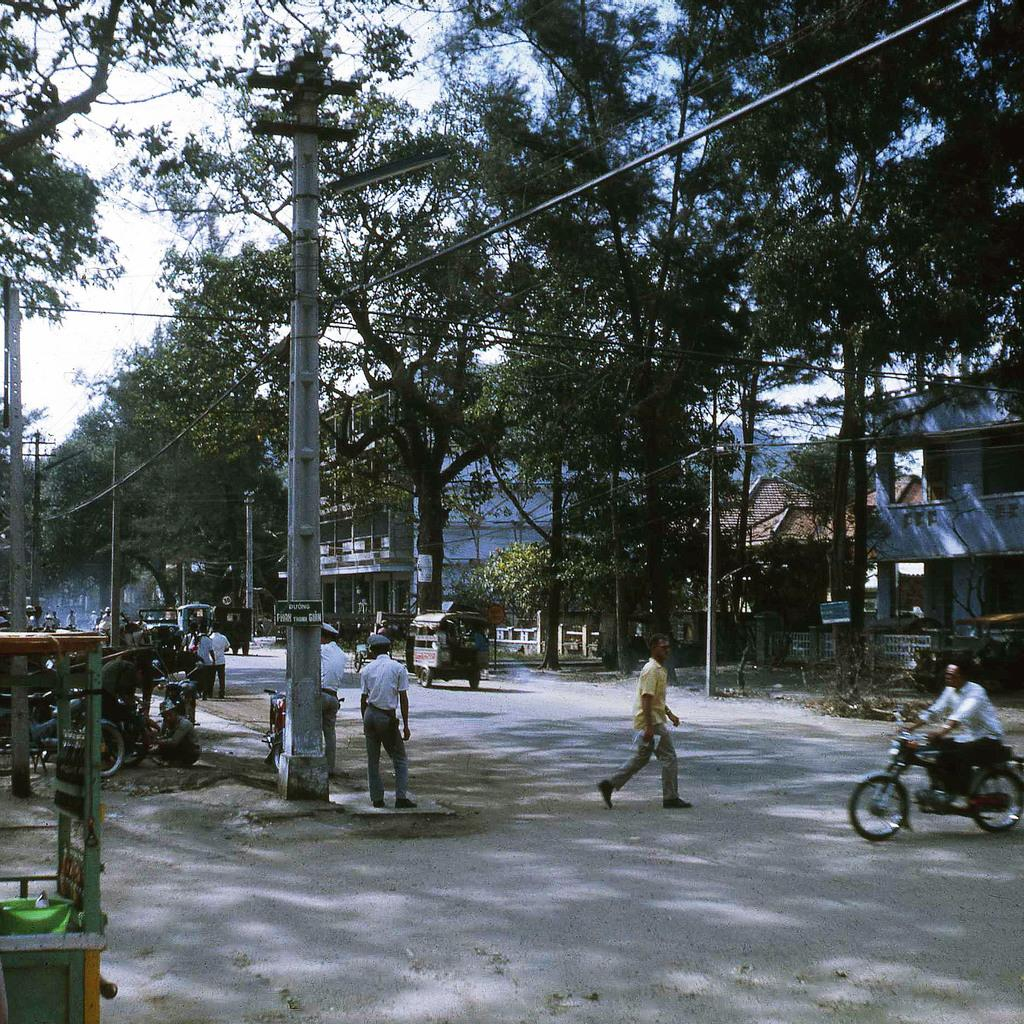What are the people in the image doing? There are persons on the road in the image, and one person is riding a bike. What can be seen in the background of the image? There is a building and trees in the image. What type of needle is being used by the person riding the bike in the image? There is no needle present in the image; the person is riding a bike. What is the end result of the persons' actions in the image? The image does not depict a specific end result or goal for the persons' actions. 